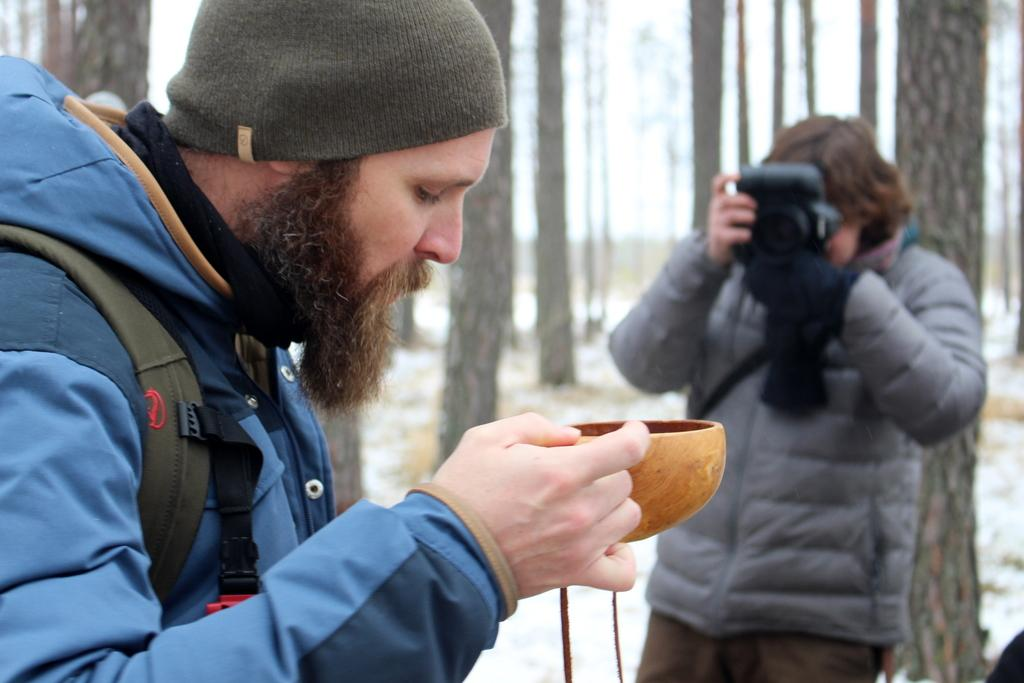What is the person holding in the image? There is a person holding an item in the image. What is the other person doing in the image? The other person is standing and holding a camera in the image. What can be seen in the background of the image? There are trees in the background of the image. What type of humor can be seen in the cave in the image? There is no cave present in the image, and therefore no humor can be observed in a cave. 